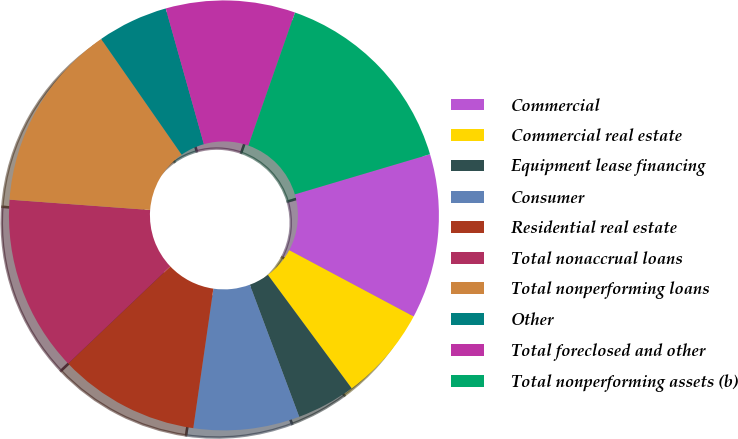Convert chart. <chart><loc_0><loc_0><loc_500><loc_500><pie_chart><fcel>Commercial<fcel>Commercial real estate<fcel>Equipment lease financing<fcel>Consumer<fcel>Residential real estate<fcel>Total nonaccrual loans<fcel>Total nonperforming loans<fcel>Other<fcel>Total foreclosed and other<fcel>Total nonperforming assets (b)<nl><fcel>12.39%<fcel>7.08%<fcel>4.43%<fcel>7.97%<fcel>10.62%<fcel>13.27%<fcel>14.16%<fcel>5.31%<fcel>9.73%<fcel>15.04%<nl></chart> 